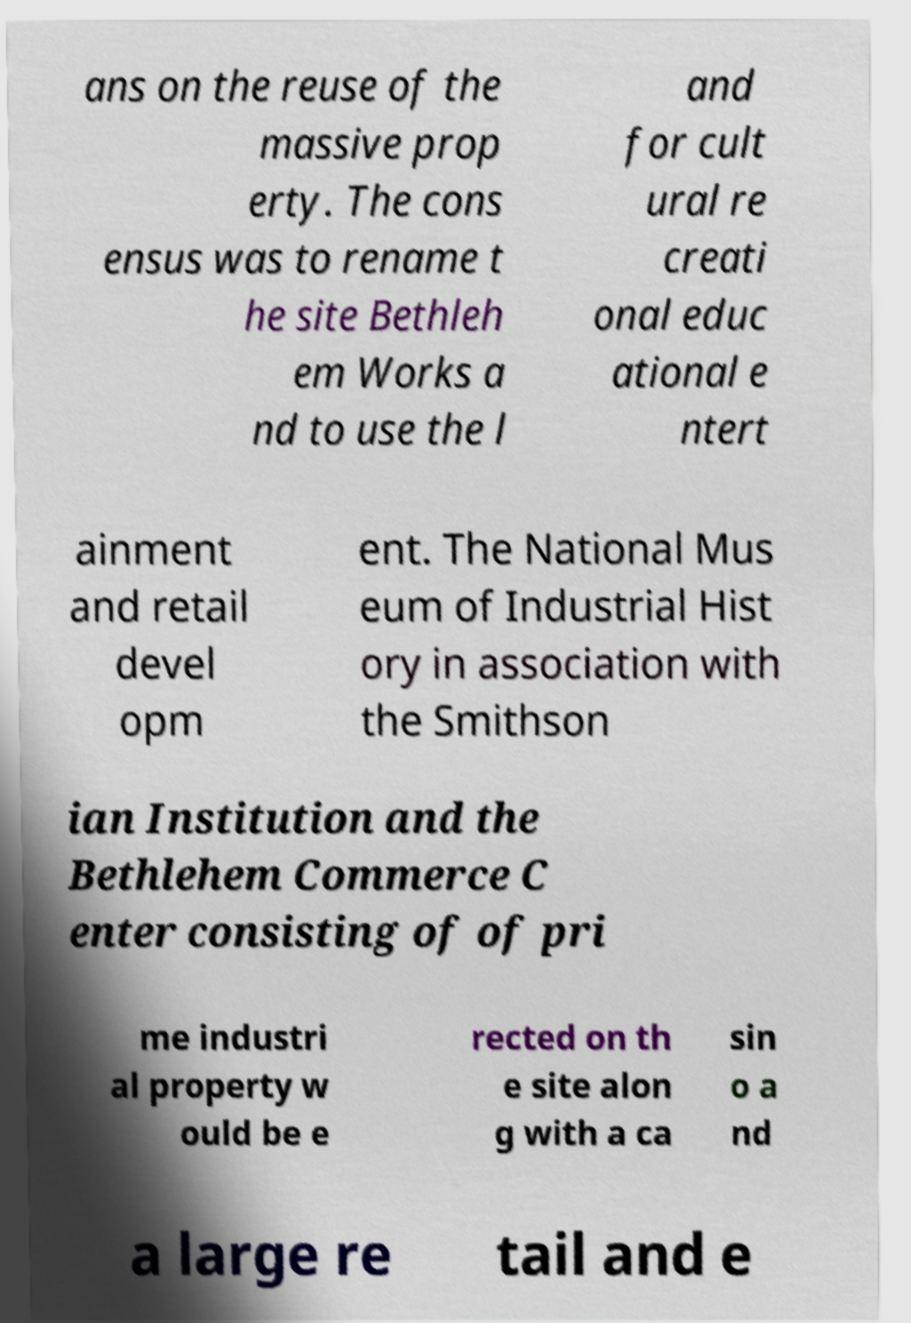Can you read and provide the text displayed in the image?This photo seems to have some interesting text. Can you extract and type it out for me? ans on the reuse of the massive prop erty. The cons ensus was to rename t he site Bethleh em Works a nd to use the l and for cult ural re creati onal educ ational e ntert ainment and retail devel opm ent. The National Mus eum of Industrial Hist ory in association with the Smithson ian Institution and the Bethlehem Commerce C enter consisting of of pri me industri al property w ould be e rected on th e site alon g with a ca sin o a nd a large re tail and e 